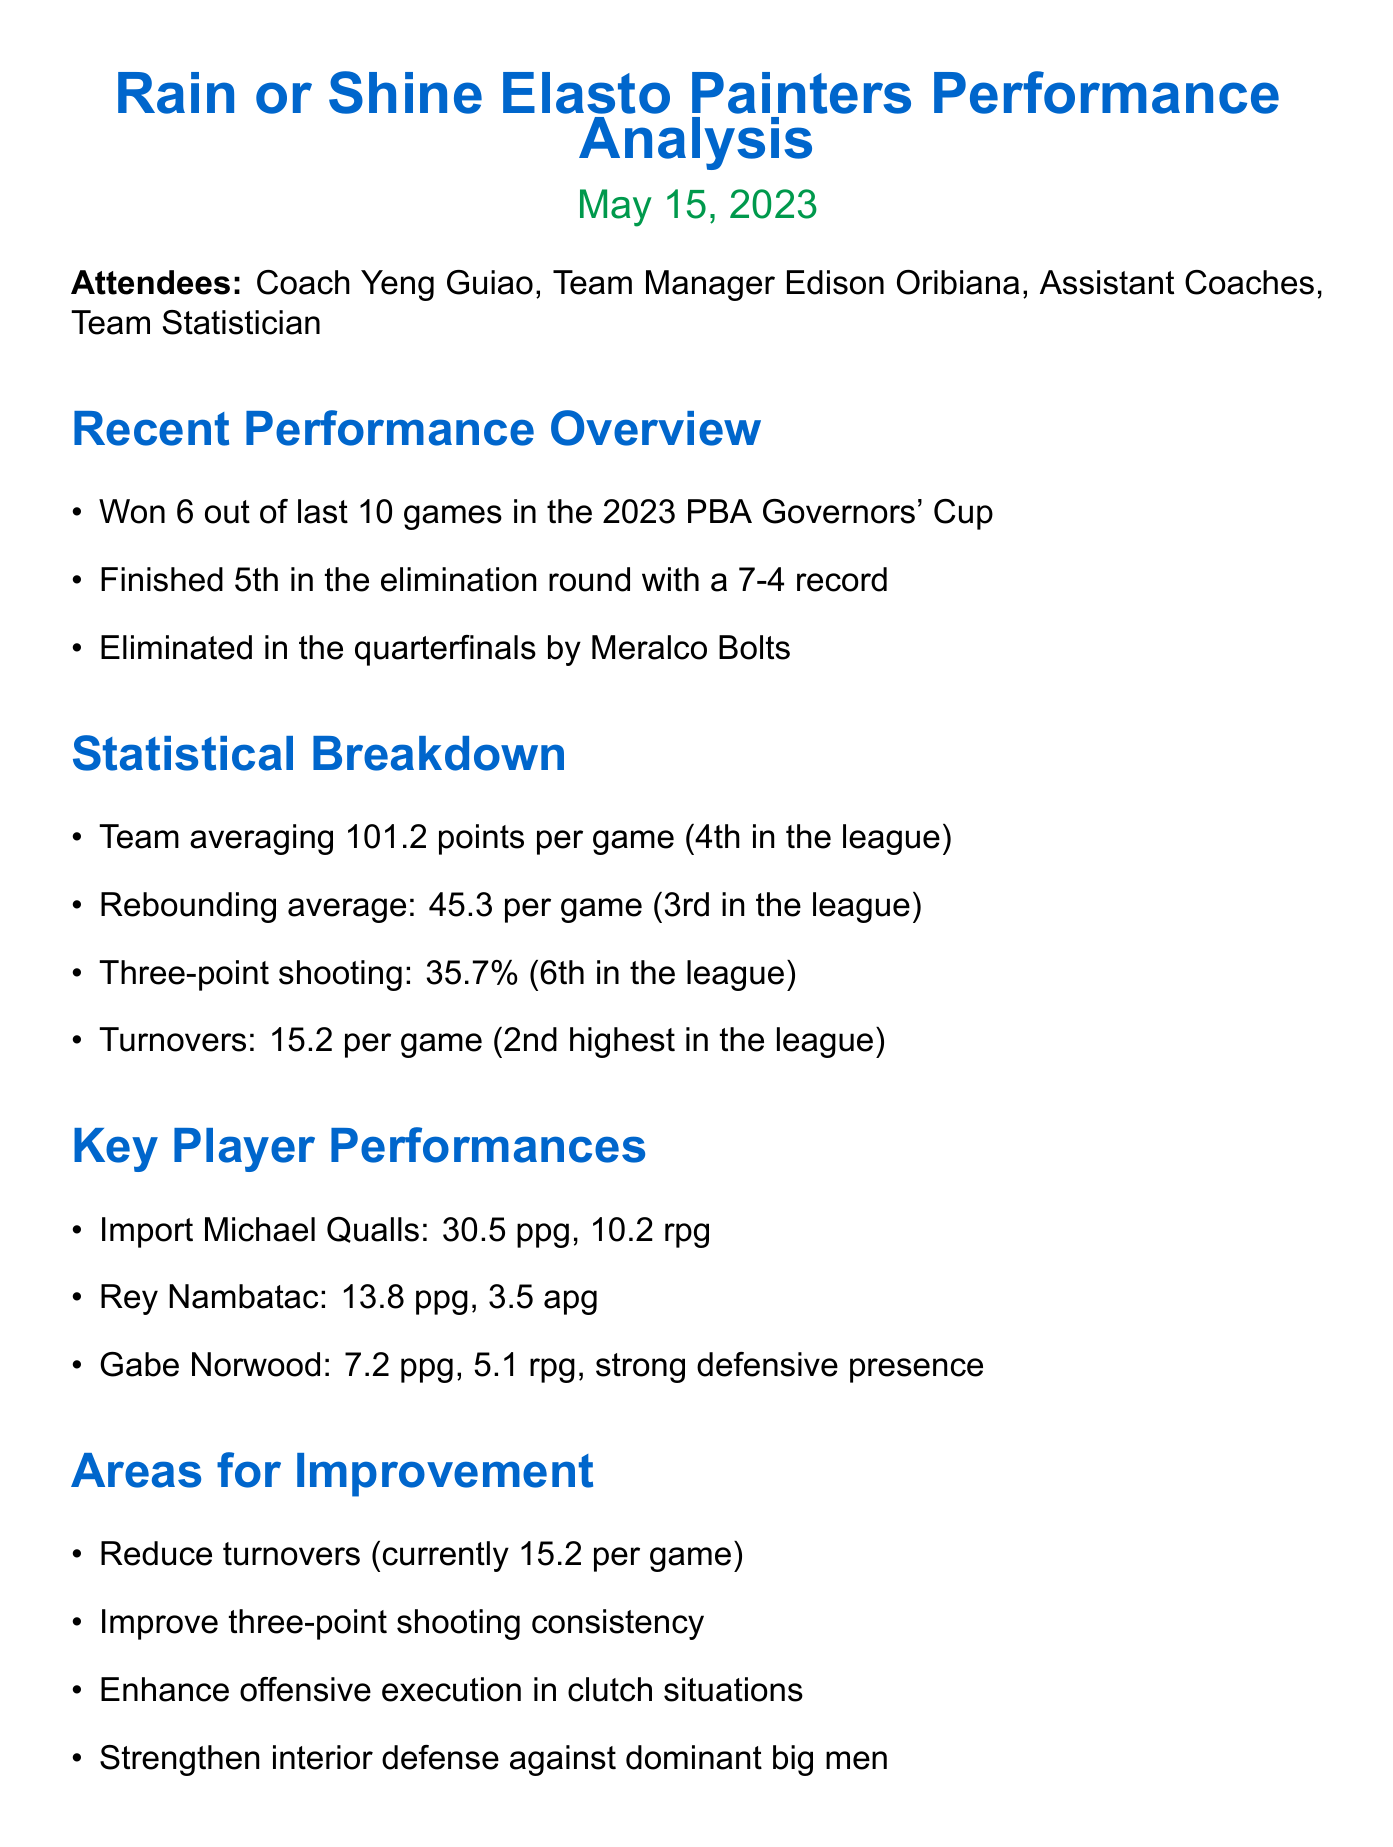What is the date of the meeting? The document states that the meeting was held on May 15, 2023.
Answer: May 15, 2023 Who is the head coach of the Rain or Shine Elasto Painters? The meeting minutes list Coach Yeng Guiao as one of the attendees, indicating he is the head coach.
Answer: Coach Yeng Guiao How many games did the team win out of the last ten? The document explicitly states that the team won 6 out of their last 10 games.
Answer: 6 What is the team's average points per game? The statistical breakdown indicates that the team averages 101.2 points per game.
Answer: 101.2 points Which area for improvement has the highest numerical value mentioned? The turnover statistic indicates the team has the second highest turnovers in the league at 15.2 per game.
Answer: 15.2 per game What action item relates to three-point shooting? One of the action items is to increase three-point shooting practice sessions, focusing on improving that area.
Answer: Increase three-point shooting practice sessions What position does Gabe Norwood play according to the document? The document does not specify his position, but describes him as having a strong defensive presence.
Answer: Strong defensive presence What was the team's rank in the elimination round? The document states that the team finished 5th in the elimination round.
Answer: 5th Who was the leading scorer for the team in points per game? Import Michael Qualls had the highest points per game at 30.5.
Answer: Michael Qualls 